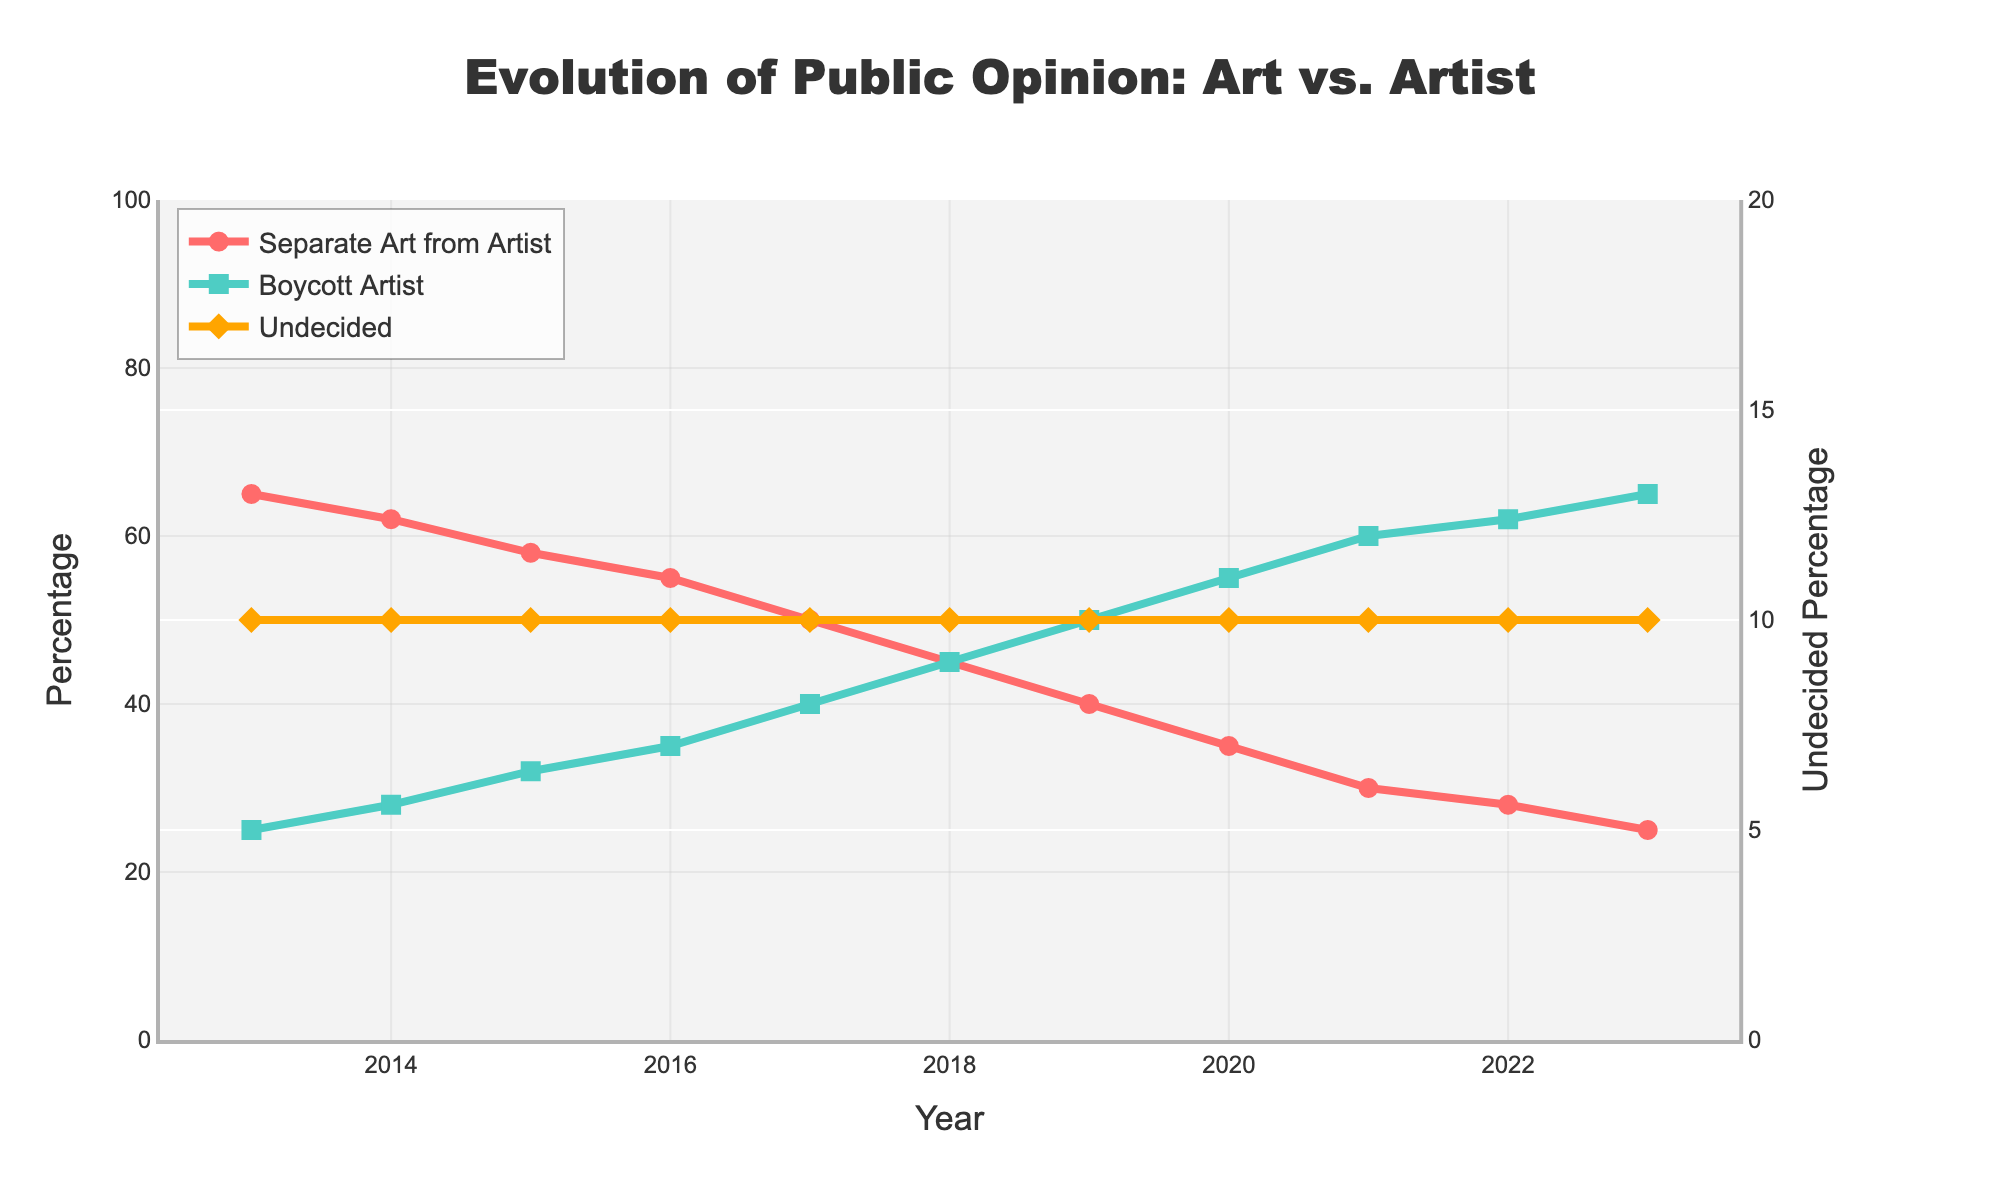What's the percentage of people who think art should be separated from the artist in 2020? Look at the "Separate Art from Artist" line on the graph for the year 2020 and read the y-axis value.
Answer: 35% What's the trend for the "Boycott Artist" opinion from 2013 to 2023? Observe the trend line labeled "Boycott Artist". It moves upward from 25% in 2013 to 65% in 2023, indicating an increase.
Answer: Increasing In what year did the "Separate Art from Artist" percentage drop below 50%? Look for the crossover point of the "Separate Art from Artist" line, which is just below 50%. It occurs around 2017.
Answer: 2017 Compare the percentage of people "Undecided" in 2021 to those in 2023. Are there any changes? Check the "Undecided" values in 2021 and 2023; they both sit around the same level (%), indicating no significant change.
Answer: No significant change What's the difference between the "Separate Art from Artist" and "Boycott Artist" opinions in 2018? Subtract the "Separate Art from Artist" value (45%) from the "Boycott Artist" value (45%) in 2018. The resulting difference is zero.
Answer: 0% Which opinion saw the highest increase over the given period? Compare the increase in both "Separate Art from Artist" and "Boycott Artist" from 2013 to 2023. "Boycott Artist" increased from 25% to 65%, while "Separate Art from Artist" decreased.
Answer: Boycott Artist What percentage of respondents were undecided in 2016? Look at the "Undecided" line for the year 2016 and read off the percentage value.
Answer: 10% How does the percentage of people wanting to "Boycott Artist" in 2013 compare to those wanting to "Separate Art from Artist" in 2013? In 2013, the "Separate Art from Artist" value is 65%, and the "Boycott Artist" value is 25%. Compare them; 65% is greater than 25%.
Answer: Greater Calculate the average percentage for the "Separate Art from Artist" opinion over the 11-year period. Sum the percentages for "Separate Art from Artist" from 2013 to 2023 and divide by 11 years. (65+62+58+55+50+45+40+35+30+28+25) / 11 = 493/11 = 44.82%
Answer: 44.82% Which opinion had a consistent level of undecided respondents over the years? Observe the "Undecided" line; it stays at 10% throughout the years 2013 to 2023.
Answer: Undecided 